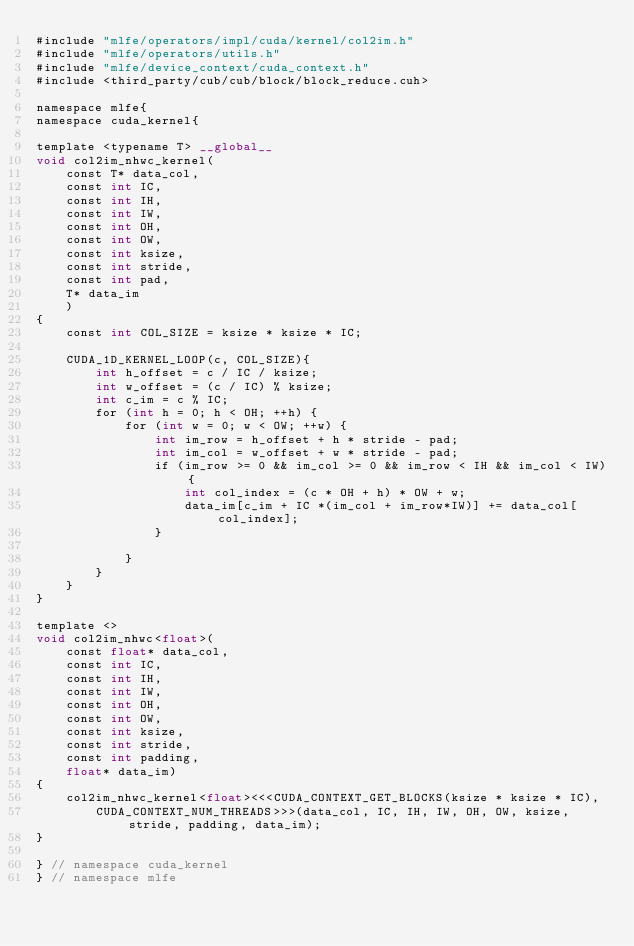<code> <loc_0><loc_0><loc_500><loc_500><_Cuda_>#include "mlfe/operators/impl/cuda/kernel/col2im.h"
#include "mlfe/operators/utils.h"
#include "mlfe/device_context/cuda_context.h"
#include <third_party/cub/cub/block/block_reduce.cuh>

namespace mlfe{
namespace cuda_kernel{

template <typename T> __global__
void col2im_nhwc_kernel(
    const T* data_col,
    const int IC,
    const int IH,
    const int IW,
    const int OH,
    const int OW,
    const int ksize,
    const int stride,
    const int pad,
    T* data_im
    )
{
    const int COL_SIZE = ksize * ksize * IC;

    CUDA_1D_KERNEL_LOOP(c, COL_SIZE){
        int h_offset = c / IC / ksize;
        int w_offset = (c / IC) % ksize;
        int c_im = c % IC;
        for (int h = 0; h < OH; ++h) {
            for (int w = 0; w < OW; ++w) {
                int im_row = h_offset + h * stride - pad;
                int im_col = w_offset + w * stride - pad;
                if (im_row >= 0 && im_col >= 0 && im_row < IH && im_col < IW){
                    int col_index = (c * OH + h) * OW + w;
                    data_im[c_im + IC *(im_col + im_row*IW)] += data_col[col_index];
                }
                
            }
        }
    }
}

template <>
void col2im_nhwc<float>(
    const float* data_col,
    const int IC,
    const int IH,
    const int IW,
    const int OH,
    const int OW,
    const int ksize,
    const int stride,
    const int padding,
    float* data_im)
{
    col2im_nhwc_kernel<float><<<CUDA_CONTEXT_GET_BLOCKS(ksize * ksize * IC),
        CUDA_CONTEXT_NUM_THREADS>>>(data_col, IC, IH, IW, OH, OW, ksize, stride, padding, data_im);
}

} // namespace cuda_kernel
} // namespace mlfe
</code> 